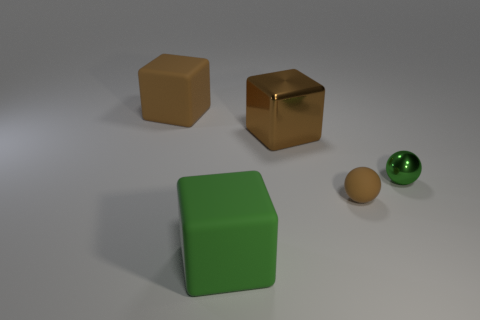Add 2 big shiny things. How many objects exist? 7 Subtract all blocks. How many objects are left? 2 Add 1 tiny green shiny things. How many tiny green shiny things are left? 2 Add 5 small gray balls. How many small gray balls exist? 5 Subtract 0 gray blocks. How many objects are left? 5 Subtract all metal blocks. Subtract all tiny things. How many objects are left? 2 